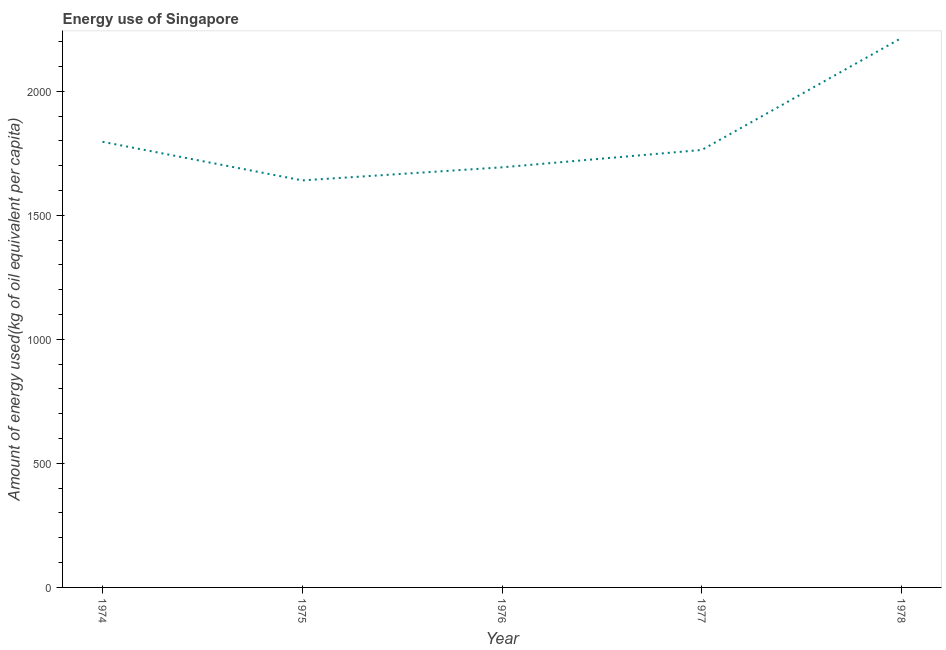What is the amount of energy used in 1978?
Make the answer very short. 2214.63. Across all years, what is the maximum amount of energy used?
Ensure brevity in your answer.  2214.63. Across all years, what is the minimum amount of energy used?
Keep it short and to the point. 1640.49. In which year was the amount of energy used maximum?
Offer a terse response. 1978. In which year was the amount of energy used minimum?
Your answer should be very brief. 1975. What is the sum of the amount of energy used?
Your answer should be compact. 9107.58. What is the difference between the amount of energy used in 1975 and 1978?
Make the answer very short. -574.14. What is the average amount of energy used per year?
Provide a short and direct response. 1821.52. What is the median amount of energy used?
Provide a succinct answer. 1763.23. In how many years, is the amount of energy used greater than 1800 kg?
Offer a very short reply. 1. Do a majority of the years between 1974 and 1975 (inclusive) have amount of energy used greater than 1300 kg?
Make the answer very short. Yes. What is the ratio of the amount of energy used in 1974 to that in 1975?
Your response must be concise. 1.09. Is the amount of energy used in 1975 less than that in 1977?
Give a very brief answer. Yes. What is the difference between the highest and the second highest amount of energy used?
Offer a very short reply. 418.65. What is the difference between the highest and the lowest amount of energy used?
Give a very brief answer. 574.14. How many years are there in the graph?
Provide a short and direct response. 5. What is the title of the graph?
Your response must be concise. Energy use of Singapore. What is the label or title of the Y-axis?
Offer a very short reply. Amount of energy used(kg of oil equivalent per capita). What is the Amount of energy used(kg of oil equivalent per capita) of 1974?
Your answer should be compact. 1795.98. What is the Amount of energy used(kg of oil equivalent per capita) in 1975?
Make the answer very short. 1640.49. What is the Amount of energy used(kg of oil equivalent per capita) in 1976?
Your answer should be compact. 1693.25. What is the Amount of energy used(kg of oil equivalent per capita) of 1977?
Ensure brevity in your answer.  1763.23. What is the Amount of energy used(kg of oil equivalent per capita) in 1978?
Your response must be concise. 2214.63. What is the difference between the Amount of energy used(kg of oil equivalent per capita) in 1974 and 1975?
Keep it short and to the point. 155.49. What is the difference between the Amount of energy used(kg of oil equivalent per capita) in 1974 and 1976?
Provide a short and direct response. 102.73. What is the difference between the Amount of energy used(kg of oil equivalent per capita) in 1974 and 1977?
Keep it short and to the point. 32.75. What is the difference between the Amount of energy used(kg of oil equivalent per capita) in 1974 and 1978?
Your response must be concise. -418.65. What is the difference between the Amount of energy used(kg of oil equivalent per capita) in 1975 and 1976?
Give a very brief answer. -52.76. What is the difference between the Amount of energy used(kg of oil equivalent per capita) in 1975 and 1977?
Offer a very short reply. -122.74. What is the difference between the Amount of energy used(kg of oil equivalent per capita) in 1975 and 1978?
Provide a succinct answer. -574.14. What is the difference between the Amount of energy used(kg of oil equivalent per capita) in 1976 and 1977?
Ensure brevity in your answer.  -69.98. What is the difference between the Amount of energy used(kg of oil equivalent per capita) in 1976 and 1978?
Offer a terse response. -521.38. What is the difference between the Amount of energy used(kg of oil equivalent per capita) in 1977 and 1978?
Your answer should be very brief. -451.4. What is the ratio of the Amount of energy used(kg of oil equivalent per capita) in 1974 to that in 1975?
Keep it short and to the point. 1.09. What is the ratio of the Amount of energy used(kg of oil equivalent per capita) in 1974 to that in 1976?
Make the answer very short. 1.06. What is the ratio of the Amount of energy used(kg of oil equivalent per capita) in 1974 to that in 1977?
Provide a succinct answer. 1.02. What is the ratio of the Amount of energy used(kg of oil equivalent per capita) in 1974 to that in 1978?
Offer a terse response. 0.81. What is the ratio of the Amount of energy used(kg of oil equivalent per capita) in 1975 to that in 1976?
Your answer should be very brief. 0.97. What is the ratio of the Amount of energy used(kg of oil equivalent per capita) in 1975 to that in 1977?
Offer a terse response. 0.93. What is the ratio of the Amount of energy used(kg of oil equivalent per capita) in 1975 to that in 1978?
Your response must be concise. 0.74. What is the ratio of the Amount of energy used(kg of oil equivalent per capita) in 1976 to that in 1977?
Offer a very short reply. 0.96. What is the ratio of the Amount of energy used(kg of oil equivalent per capita) in 1976 to that in 1978?
Offer a very short reply. 0.77. What is the ratio of the Amount of energy used(kg of oil equivalent per capita) in 1977 to that in 1978?
Provide a short and direct response. 0.8. 